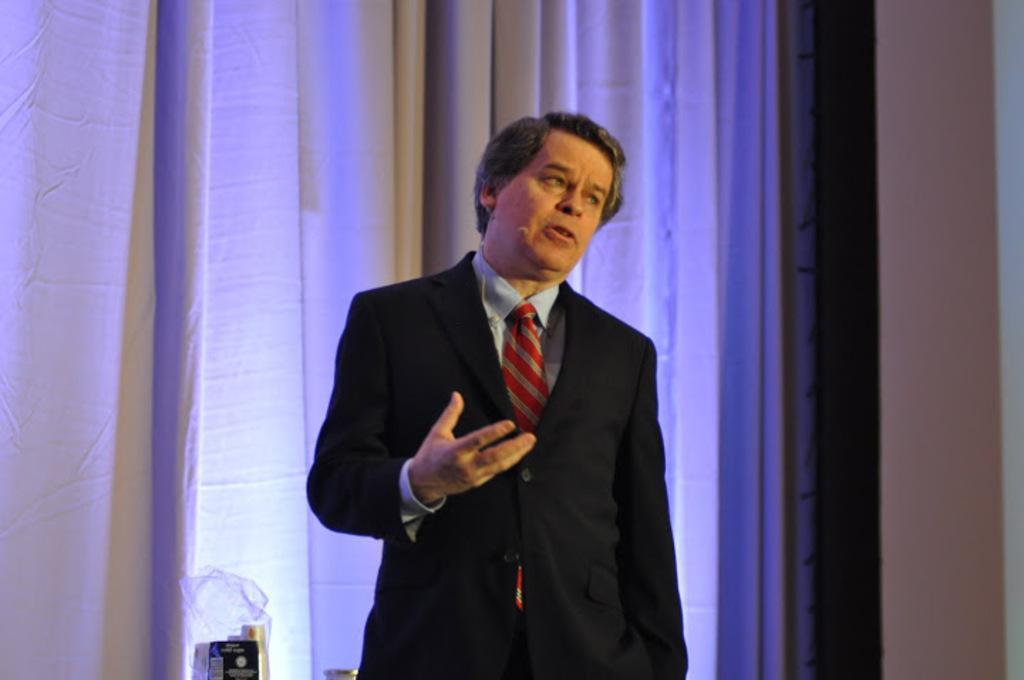Please provide a concise description of this image. Here I can see a man wearing a black color suit, standing and speaking by looking at the right side. In the background there is a curtain. On the right side there is a wall. At the bottom there are few objects. 